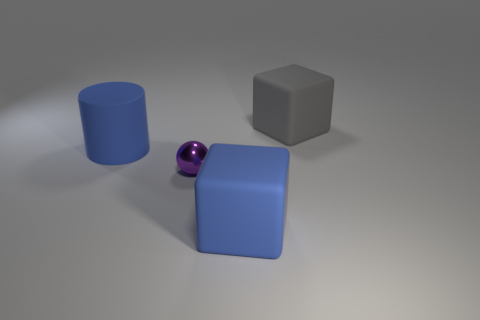Does the tiny ball have the same color as the big cube that is behind the big cylinder?
Make the answer very short. No. What color is the rubber block behind the big block in front of the gray rubber block?
Make the answer very short. Gray. Is there any other thing that is the same size as the sphere?
Your response must be concise. No. There is a blue matte thing that is on the left side of the tiny shiny sphere; does it have the same shape as the tiny purple metal thing?
Your response must be concise. No. What number of objects are right of the purple sphere and in front of the blue matte cylinder?
Offer a terse response. 1. There is a matte cylinder that is behind the purple ball that is to the right of the blue rubber cylinder that is behind the tiny purple metal ball; what color is it?
Make the answer very short. Blue. There is a big cube that is in front of the gray thing; what number of big cubes are to the right of it?
Keep it short and to the point. 1. What number of other objects are there of the same shape as the purple thing?
Make the answer very short. 0. How many things are either purple cubes or matte blocks on the right side of the blue block?
Offer a very short reply. 1. Are there more cylinders that are to the right of the large cylinder than tiny things that are to the right of the blue rubber cube?
Keep it short and to the point. No. 